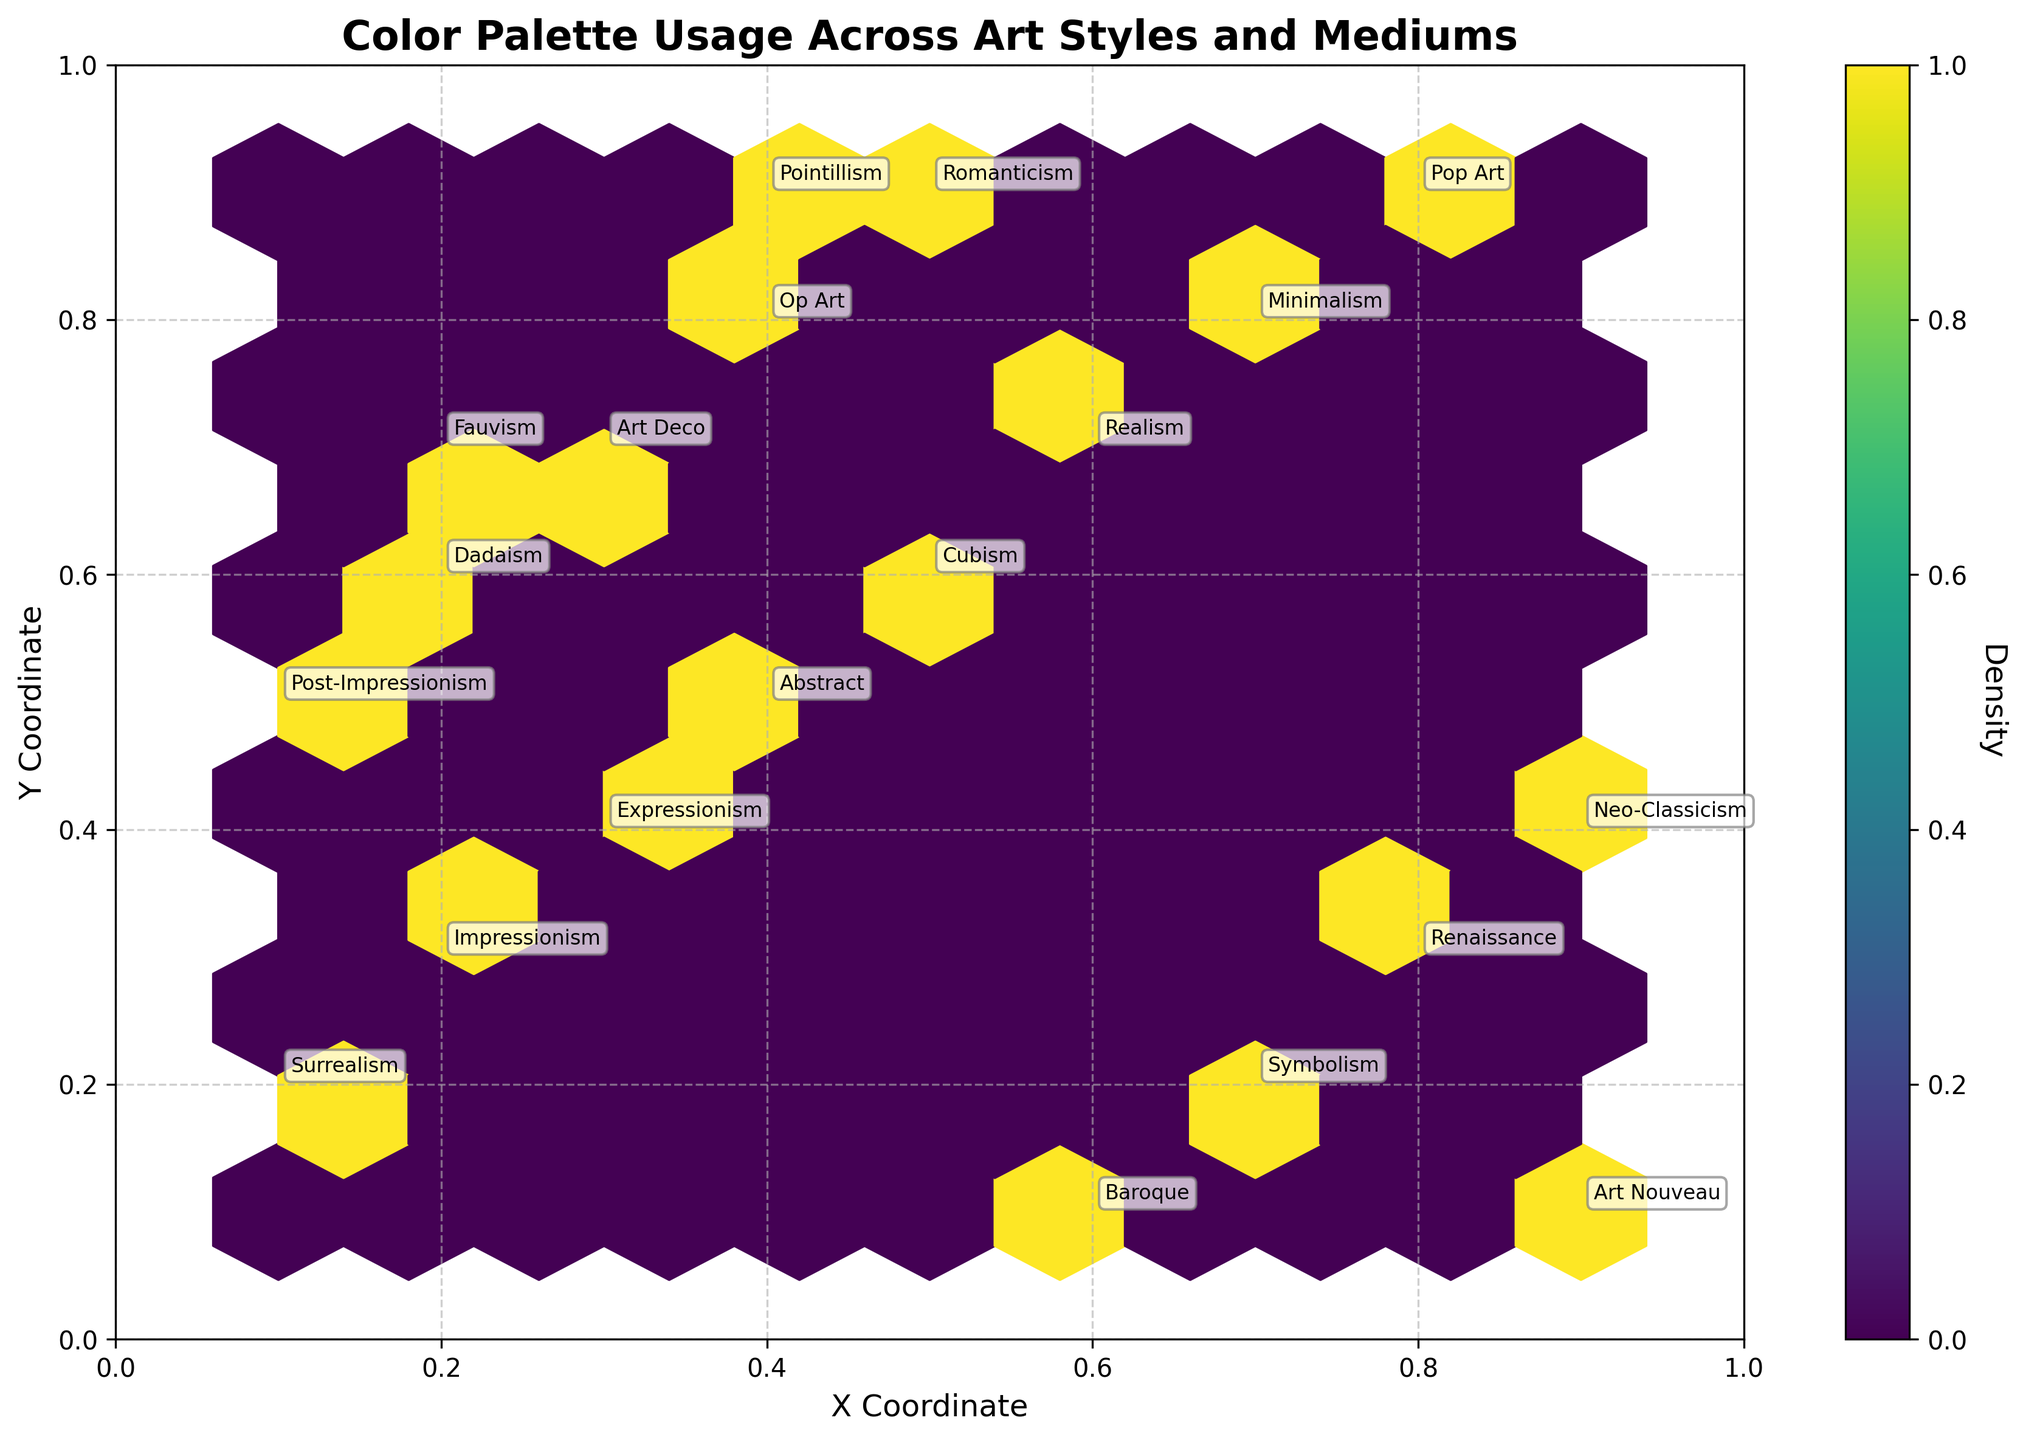What is the title of the plot? Look at the top of the plot to find the title. It reads 'Color Palette Usage Across Art Styles and Mediums'
Answer: Color Palette Usage Across Art Styles and Mediums How many data points are there on the plot? Count the number of annotations corresponding to each data point. Each style and medium pair represents a data point. There are 20 such points.
Answer: 20 What are the x and y coordinates representing in this plot? The x and y coordinates are subjective values representing different dimensions of color palette usage. They don't have specific units but provide relative positions of the styles.
Answer: Subjective dimensions of color palette usage Which art style has the highest density of usage based on the hexbin plot? Identify the densest area on the hexbin plot where the hexagons are darker. Impressionism, Oil is in the densest region.
Answer: Impressionism, Oil Between Impressionism and Abstract, which style is positioned higher on the y-axis? Locate both styles on the plot and compare their y coordinates. Impressionism is at (0.2, 0.3) and Abstract is at (0.4, 0.5). Abstract is higher.
Answer: Abstract What medium is associated with Pop Art according to the annotations? Look at the annotation for Pop Art on the plot, which indicates it is associated with Mixed Media.
Answer: Mixed Media Is there more than one art style in the plot that uses Watercolor as a medium? Identify and count the styles labeled with Watercolor. Realism, Art Nouveau, and Symbolism are all using Watercolor.
Answer: Yes Which art style is closer to the center of the plot, Renaissance or Baroque? Compare the coordinates of Renaissance (0.8, 0.3) and Baroque (0.6, 0.1) to the center (0.5, 0.5). Baroque is closer to the center.
Answer: Baroque Describe the distribution of mediums across different art styles. Examine the annotations for each data point to determine the mediums used by different styles. It reveals multiple mediums including Oil, Acrylic, Watercolor, Mixed Media, Sculpture, Collage, and Fresco, distributed across various art styles.
Answer: Various mediums distributed across art styles 